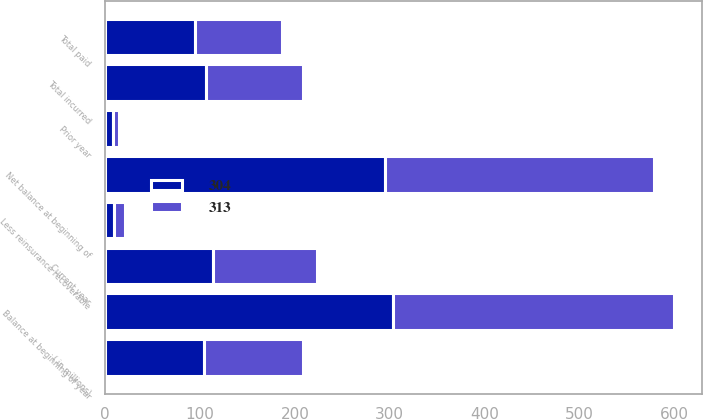<chart> <loc_0><loc_0><loc_500><loc_500><stacked_bar_chart><ecel><fcel>( in millions)<fcel>Balance at beginning of year<fcel>Less reinsurance recoverable<fcel>Net balance at beginning of<fcel>Current year<fcel>Prior year<fcel>Total incurred<fcel>Total paid<nl><fcel>304<fcel>104.5<fcel>304<fcel>9<fcel>295<fcel>114<fcel>8<fcel>106<fcel>95<nl><fcel>313<fcel>104.5<fcel>296<fcel>12<fcel>284<fcel>109<fcel>6<fcel>103<fcel>92<nl></chart> 